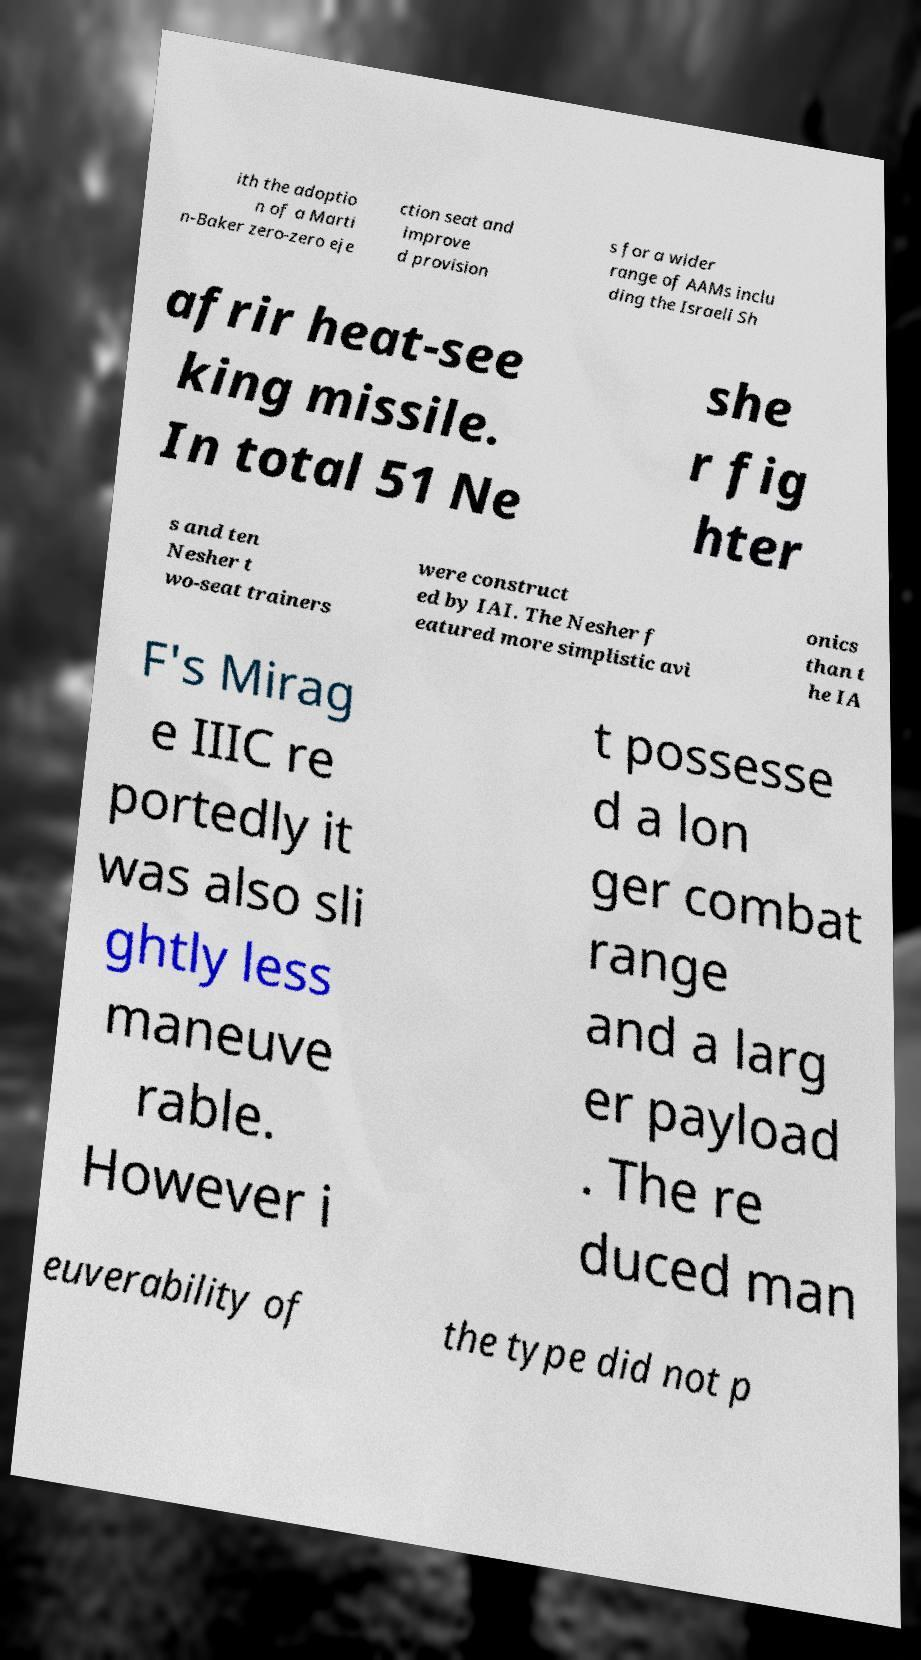What messages or text are displayed in this image? I need them in a readable, typed format. ith the adoptio n of a Marti n-Baker zero-zero eje ction seat and improve d provision s for a wider range of AAMs inclu ding the Israeli Sh afrir heat-see king missile. In total 51 Ne she r fig hter s and ten Nesher t wo-seat trainers were construct ed by IAI. The Nesher f eatured more simplistic avi onics than t he IA F's Mirag e IIIC re portedly it was also sli ghtly less maneuve rable. However i t possesse d a lon ger combat range and a larg er payload . The re duced man euverability of the type did not p 